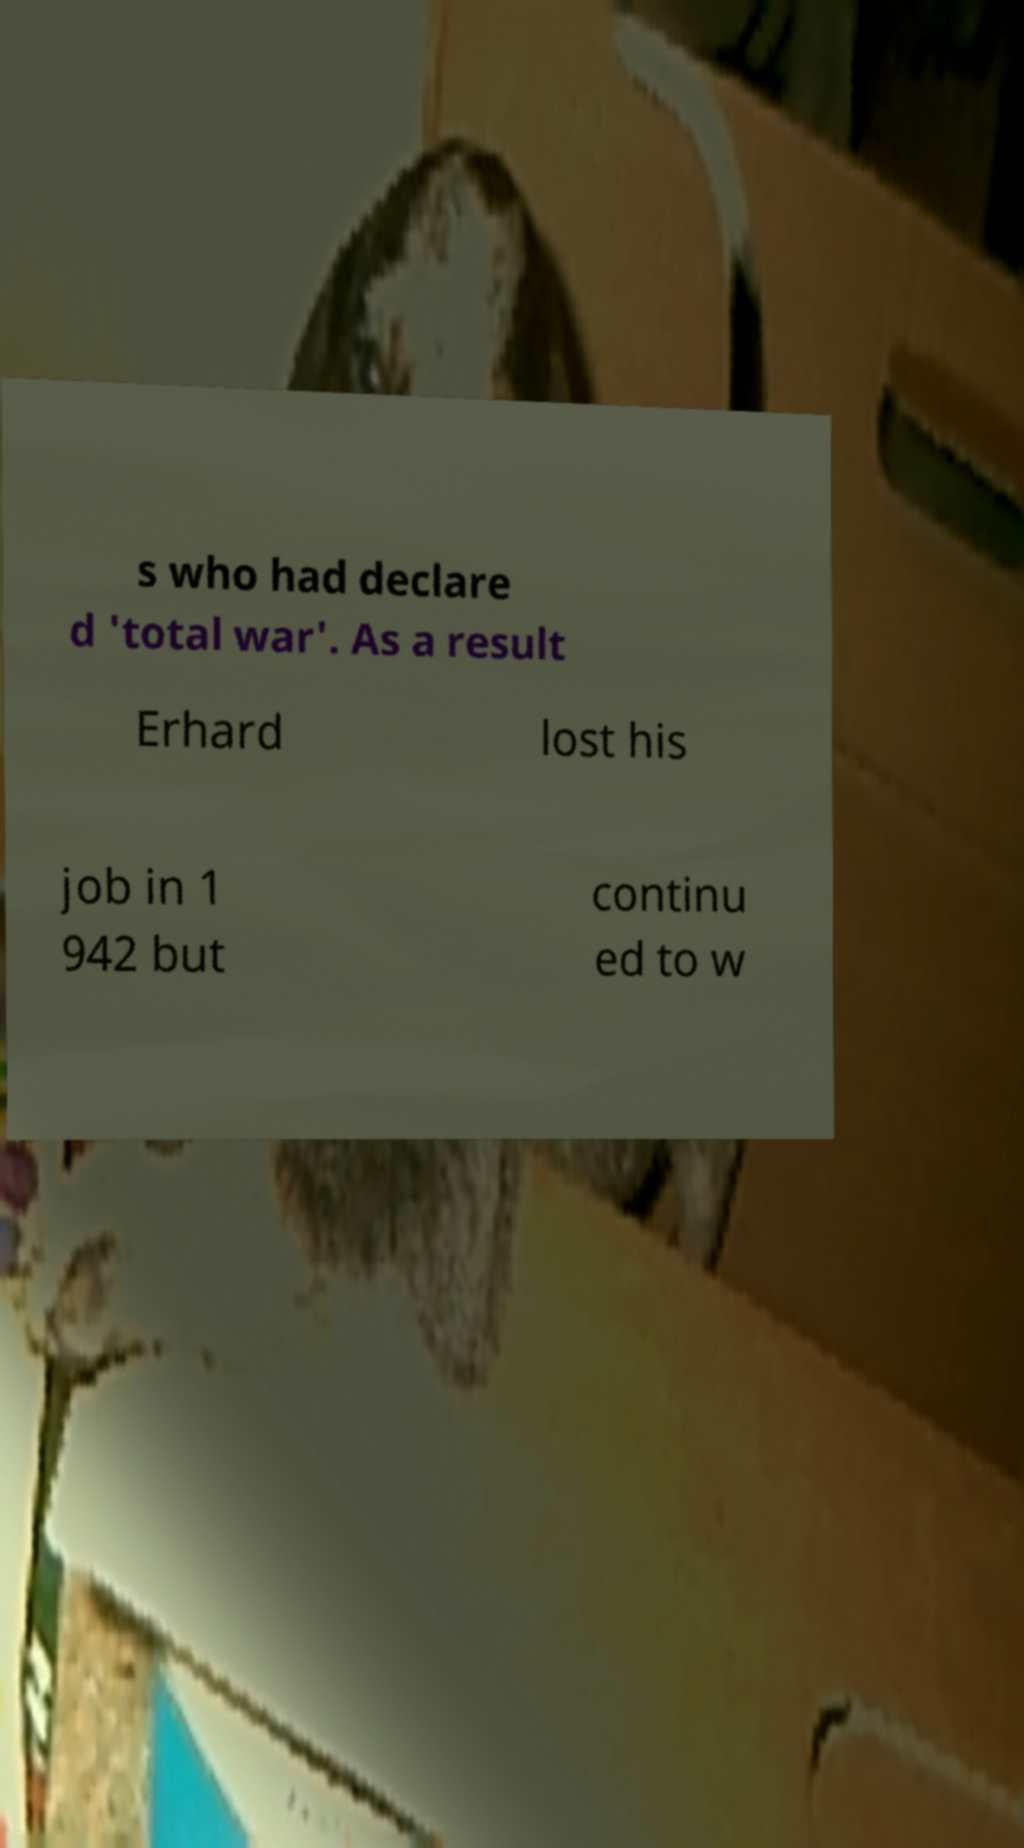Could you assist in decoding the text presented in this image and type it out clearly? s who had declare d 'total war'. As a result Erhard lost his job in 1 942 but continu ed to w 